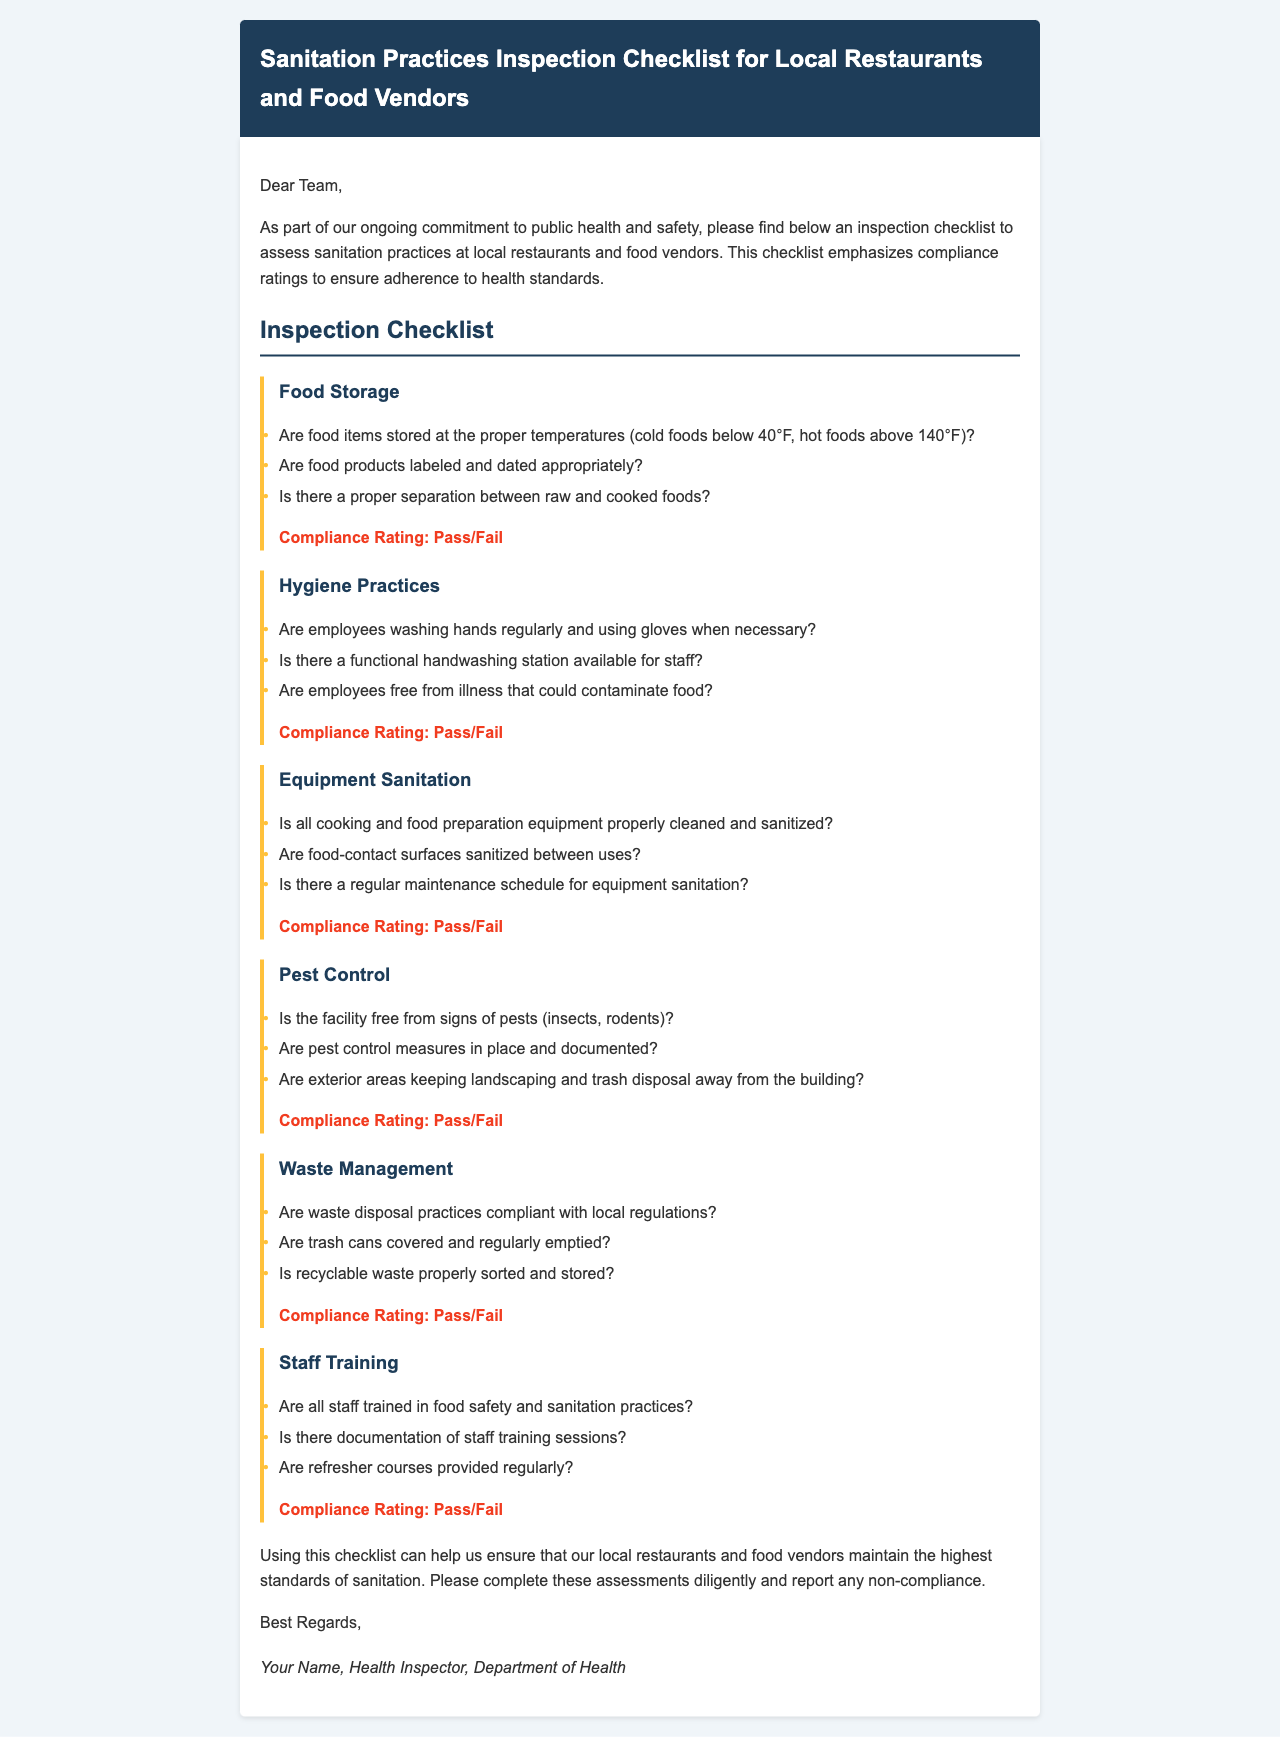What is the title of the document? The title is stated at the top of the document under the header section, indicating its main focus on sanitation practices.
Answer: Sanitation Practices Inspection Checklist for Local Restaurants and Food Vendors What section addresses food storage? The section titles are listed in a structured way, with "Food Storage" being specifically mentioned as one of the checklist items.
Answer: Food Storage What are the compliance ratings mentioned in the document? Compliance ratings are indicated after each section, describing the assessment outcome for the respective area.
Answer: Pass/Fail How many areas are included in the inspection checklist? The number of checklist items (areas) can be counted from the main sections outlined in the document.
Answer: Six What is required from employees regarding hygiene practices? The checklist specifically lists requirements for employee actions related to hygiene, illustrating compliance expectations.
Answer: Washing hands regularly and using gloves What should be documented according to the pest control section? The pest control section mentions documentation as an essential part of the pest control measures, ensuring accountability.
Answer: Pest control measures What type of training is mentioned for staff? The document emphasizes the need for staff training in a specific area of focus to maintain compliance and ensure food safety.
Answer: Food safety and sanitation practices How should recyclable waste be managed? The waste management section provides guidance on the appropriate handling of recyclable materials to meet sanitation standards.
Answer: Properly sorted and stored 